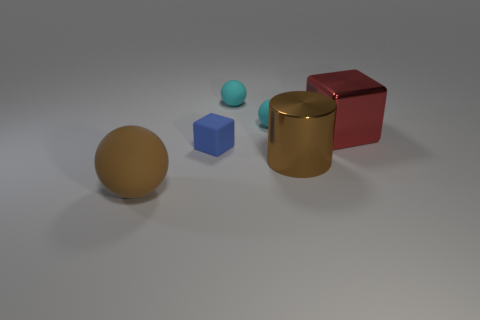How many small rubber things are to the left of the big brown thing to the right of the tiny matte object in front of the metallic block? There are three small rubber balls to the left of the big brown box, which is to the right of the tiny blue cube in front of the metallic cylinder. 